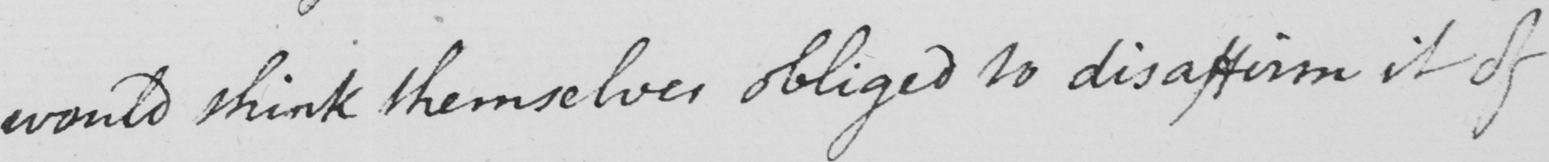What is written in this line of handwriting? would think themselves obliged to disaffirm it of 